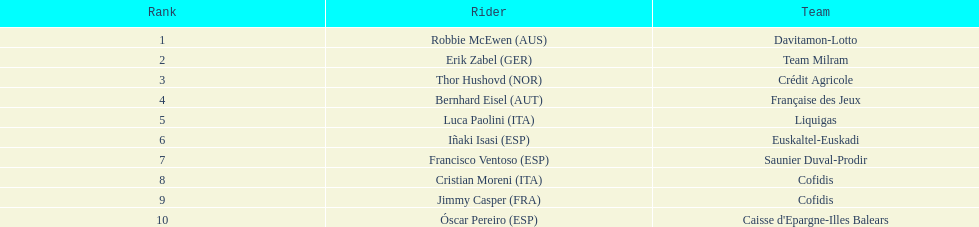How many points did robbie mcewen and cristian moreni score together? 404. 